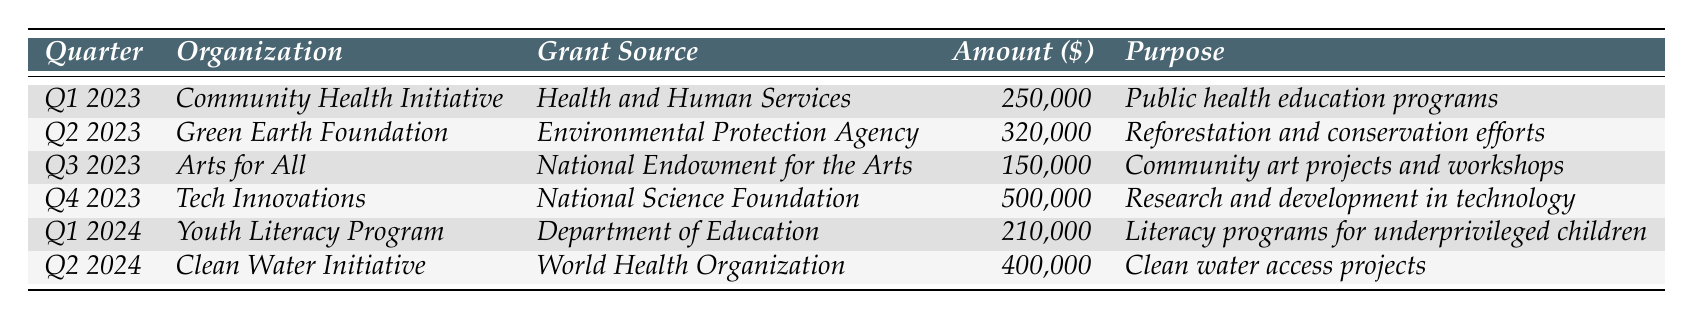What was the amount of grant revenue for Tech Innovations in Q4 2023? Looking at the table, Tech Innovations received $500,000 in Q4 2023.
Answer: $500,000 Which organization received the largest grant in Q2 2024? The Clean Water Initiative received $400,000 in Q2 2024, which is more than any other organization in that quarter.
Answer: Clean Water Initiative What is the total amount of grant revenue from all sources for Q1 2023 and Q2 2023? The amounts for Q1 2023 ($250,000) and Q2 2023 ($320,000) need to be summed: 250,000 + 320,000 = 570,000.
Answer: $570,000 Did any organization receive less than $200,000 in grant revenue in 2023? Yes, Arts for All received $150,000 in Q3 2023, which is less than $200,000.
Answer: Yes What was the average amount of grant revenue across all quarters listed in the table? To find the average, first sum all the grants: 250,000 + 320,000 + 150,000 + 500,000 + 210,000 + 400,000 = 1,830,000. There are 6 quarters, so the average is 1,830,000 / 6 = 305,000.
Answer: $305,000 Which quarter had the highest grant revenue, and what was the amount? Q4 2023 had the highest grant revenue of $500,000, making it the quarter with the greatest funding received.
Answer: Q4 2023, $500,000 How many unique organizations received grants in 2023? The organizations listed in 2023 are Community Health Initiative, Green Earth Foundation, Arts for All, and Tech Innovations, which totals to four unique organizations.
Answer: 4 What is the difference in grant revenue between Q2 2023 and Q3 2023? Q2 2023 had $320,000, and Q3 2023 had $150,000. The difference is calculated as 320,000 - 150,000 = 170,000.
Answer: $170,000 Is there a trend of increasing grant revenue from Q1 2023 to Q2 2024? When comparing each quarter, the revenue increases from Q1 2023 to Q2 2024, starting at $250,000 in Q1 2023 and reaching $400,000 in Q2 2024.
Answer: Yes Which grant source provided funding for community art projects in Q3 2023? The grant source for Arts for All, which focused on community art projects in Q3 2023, is the National Endowment for the Arts.
Answer: National Endowment for the Arts 